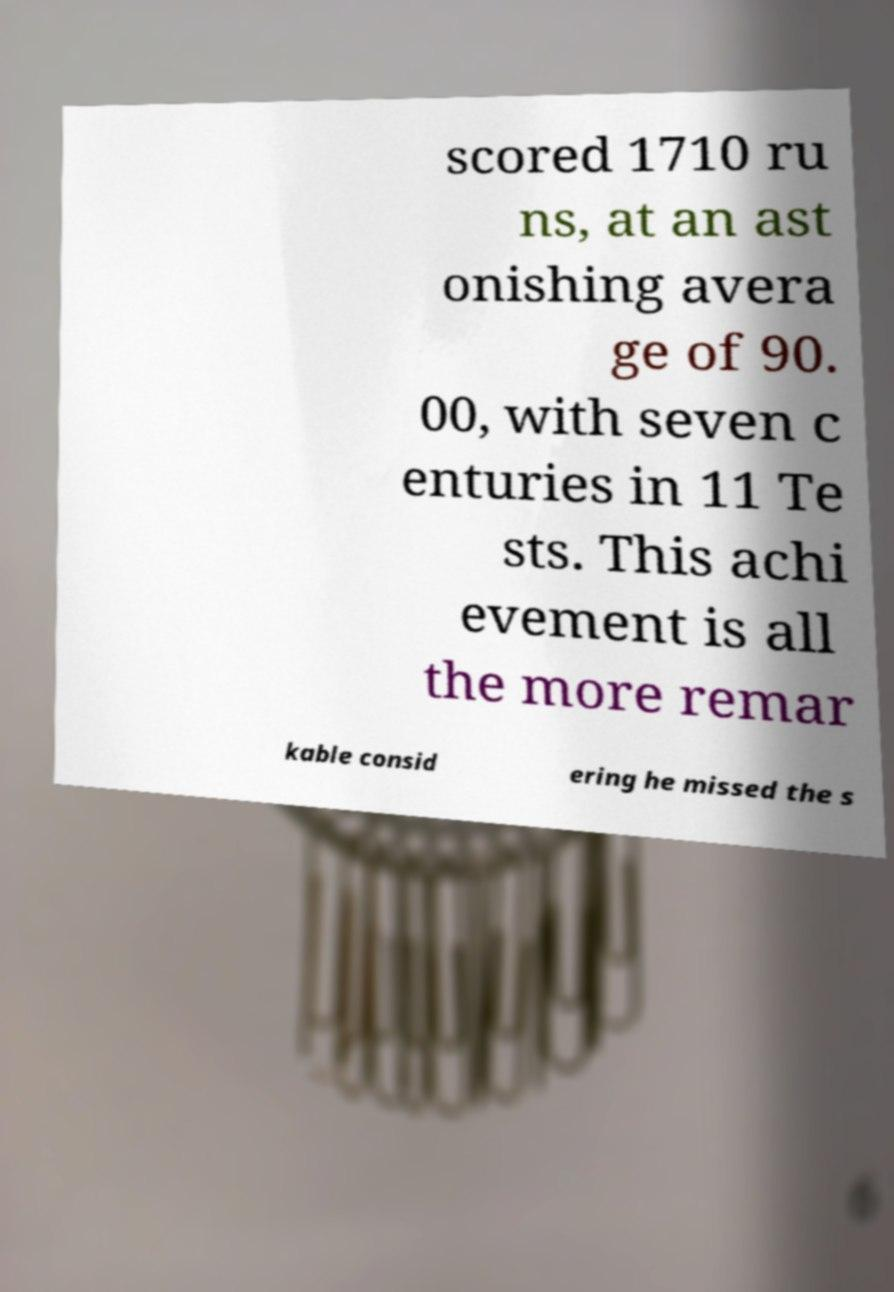Can you accurately transcribe the text from the provided image for me? scored 1710 ru ns, at an ast onishing avera ge of 90. 00, with seven c enturies in 11 Te sts. This achi evement is all the more remar kable consid ering he missed the s 